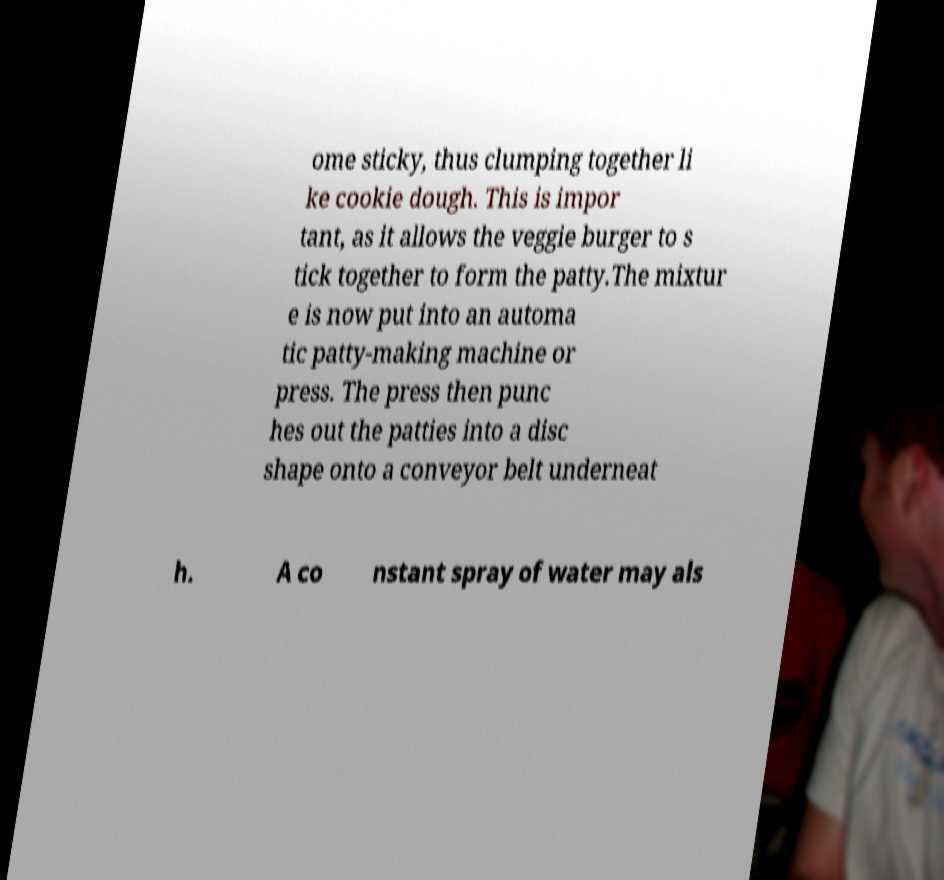I need the written content from this picture converted into text. Can you do that? ome sticky, thus clumping together li ke cookie dough. This is impor tant, as it allows the veggie burger to s tick together to form the patty.The mixtur e is now put into an automa tic patty-making machine or press. The press then punc hes out the patties into a disc shape onto a conveyor belt underneat h. A co nstant spray of water may als 